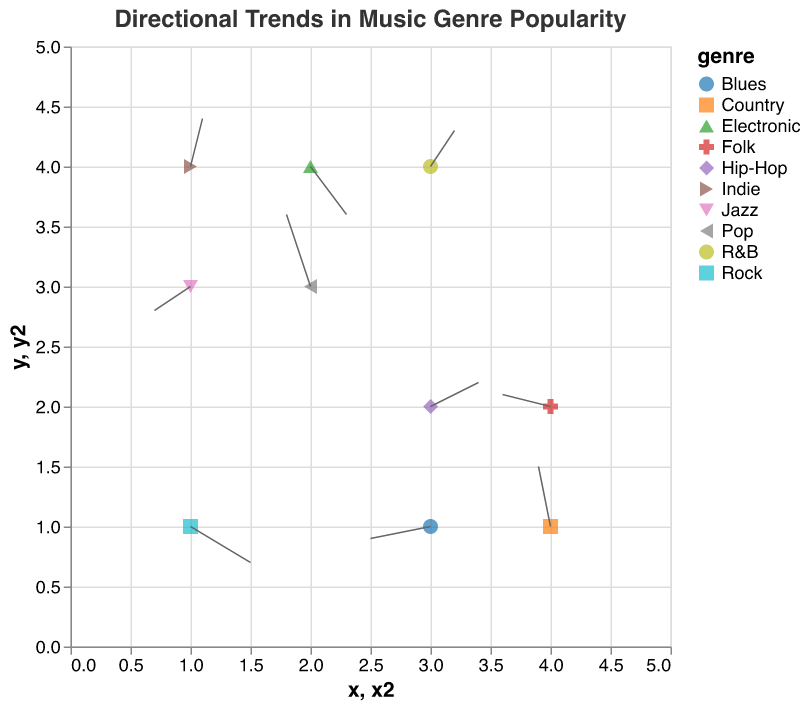What's the title of the figure? The title can be found at the top of the figure as a text label. It describes the overall subject of the plot.
Answer: Directional Trends in Music Genre Popularity How many music genres are represented in the plot? Each genre is represented by a unique color and shape in the legend, and there is one point per genre. By counting the distinct entries in the legend, we determine the number of represented genres.
Answer: 10 Which genre shows a trend moving primarily downward? To find this, look for vectors (arrows) with a negative v component. For example, Jazz at (1,3) has its vector pointing primarily downward as indicated by its negative v component.
Answer: Jazz Where is the R&B genre located on the plot? Check for the coordinates given for R&B. According to the data, it matches the coordinates (3, 4).
Answer: (3, 4) Which genre has the longest arrow, indicating the most significant trend direction? To determine the longest arrow, calculate the magnitude sqrt(u^2 + v^2) for each vector. The genre with the highest magnitude indicates the most significant trend. For example, Indie has u=0.1 and v=0.4, so its magnitude = sqrt(0.1^2 + 0.4^2) = 0.41, which is not the longest. By calculating similarly, Rock has u=0.5 and v=-0.3, so its magnitude = sqrt(0.5^2 + (-0.3)^2) ≈ 0.58, which is the longest.
Answer: Rock Which region has the most genres starting from it? Count the number of data points (or vectors) originating from each x and y coordinate. The coordinate with the highest count has the most genres starting from it.
Answer: 1, 4 What direction is the trend for Country music moving in? Look at the vector originating from Country music’s position (4,1). The u, v components for Country are -0.1 and 0.5, indicating a trend direction moving left and upward.
Answer: Left and upward Compare the trend directions for Electronic and Folk. Which genre shows a more downward trend? Compare the v components of Electronic (0.3, -0.4) and Folk (-0.4, 0.1). The genre with the more negative v indicates a stronger downward trend. Electronic's v=-0.4 is more negative than Folk's v=0.1.
Answer: Electronic Which genre is showing the least movement? Calculate the magnitude sqrt(u^2 + v^2) for each genre and find the smallest value. For example, examining Folk's magnitude sqrt((-0.4)^2 + 0.1^2) ≈ 0.41 and comparing it to others, if none have a smaller magnitude, then Folk has the least movement.
Answer: Folk 